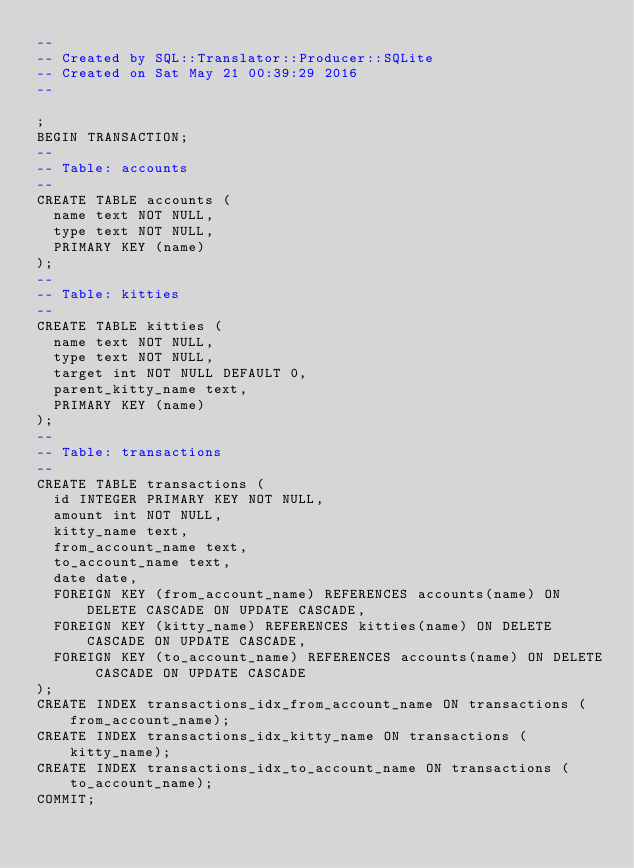<code> <loc_0><loc_0><loc_500><loc_500><_SQL_>-- 
-- Created by SQL::Translator::Producer::SQLite
-- Created on Sat May 21 00:39:29 2016
-- 

;
BEGIN TRANSACTION;
--
-- Table: accounts
--
CREATE TABLE accounts (
  name text NOT NULL,
  type text NOT NULL,
  PRIMARY KEY (name)
);
--
-- Table: kitties
--
CREATE TABLE kitties (
  name text NOT NULL,
  type text NOT NULL,
  target int NOT NULL DEFAULT 0,
  parent_kitty_name text,
  PRIMARY KEY (name)
);
--
-- Table: transactions
--
CREATE TABLE transactions (
  id INTEGER PRIMARY KEY NOT NULL,
  amount int NOT NULL,
  kitty_name text,
  from_account_name text,
  to_account_name text,
  date date,
  FOREIGN KEY (from_account_name) REFERENCES accounts(name) ON DELETE CASCADE ON UPDATE CASCADE,
  FOREIGN KEY (kitty_name) REFERENCES kitties(name) ON DELETE CASCADE ON UPDATE CASCADE,
  FOREIGN KEY (to_account_name) REFERENCES accounts(name) ON DELETE CASCADE ON UPDATE CASCADE
);
CREATE INDEX transactions_idx_from_account_name ON transactions (from_account_name);
CREATE INDEX transactions_idx_kitty_name ON transactions (kitty_name);
CREATE INDEX transactions_idx_to_account_name ON transactions (to_account_name);
COMMIT;
</code> 